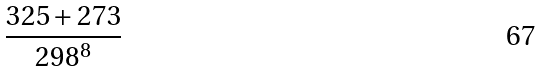<formula> <loc_0><loc_0><loc_500><loc_500>\frac { 3 2 5 + 2 7 3 } { 2 9 8 ^ { 8 } }</formula> 